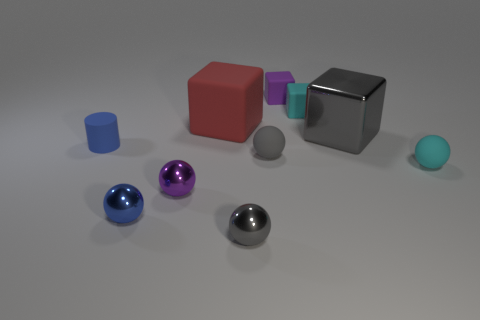There is a blue object that is made of the same material as the red object; what is its size?
Offer a terse response. Small. How big is the cyan matte thing left of the large cube that is to the right of the tiny purple thing that is behind the blue cylinder?
Provide a succinct answer. Small. There is a purple shiny object in front of the small purple cube; how big is it?
Give a very brief answer. Small. How many gray objects are big rubber things or spheres?
Your response must be concise. 2. Are there any cyan matte balls that have the same size as the cyan cube?
Your response must be concise. Yes. What is the material of the purple object that is the same size as the purple cube?
Your answer should be compact. Metal. Do the rubber object that is on the left side of the big red object and the gray sphere that is behind the gray metal ball have the same size?
Your response must be concise. Yes. What number of things are either blue matte cylinders or small matte spheres on the right side of the tiny rubber cylinder?
Give a very brief answer. 3. Is there a tiny purple shiny object of the same shape as the tiny purple rubber object?
Provide a succinct answer. No. There is a gray matte sphere to the left of the metallic thing behind the blue cylinder; what is its size?
Your answer should be compact. Small. 